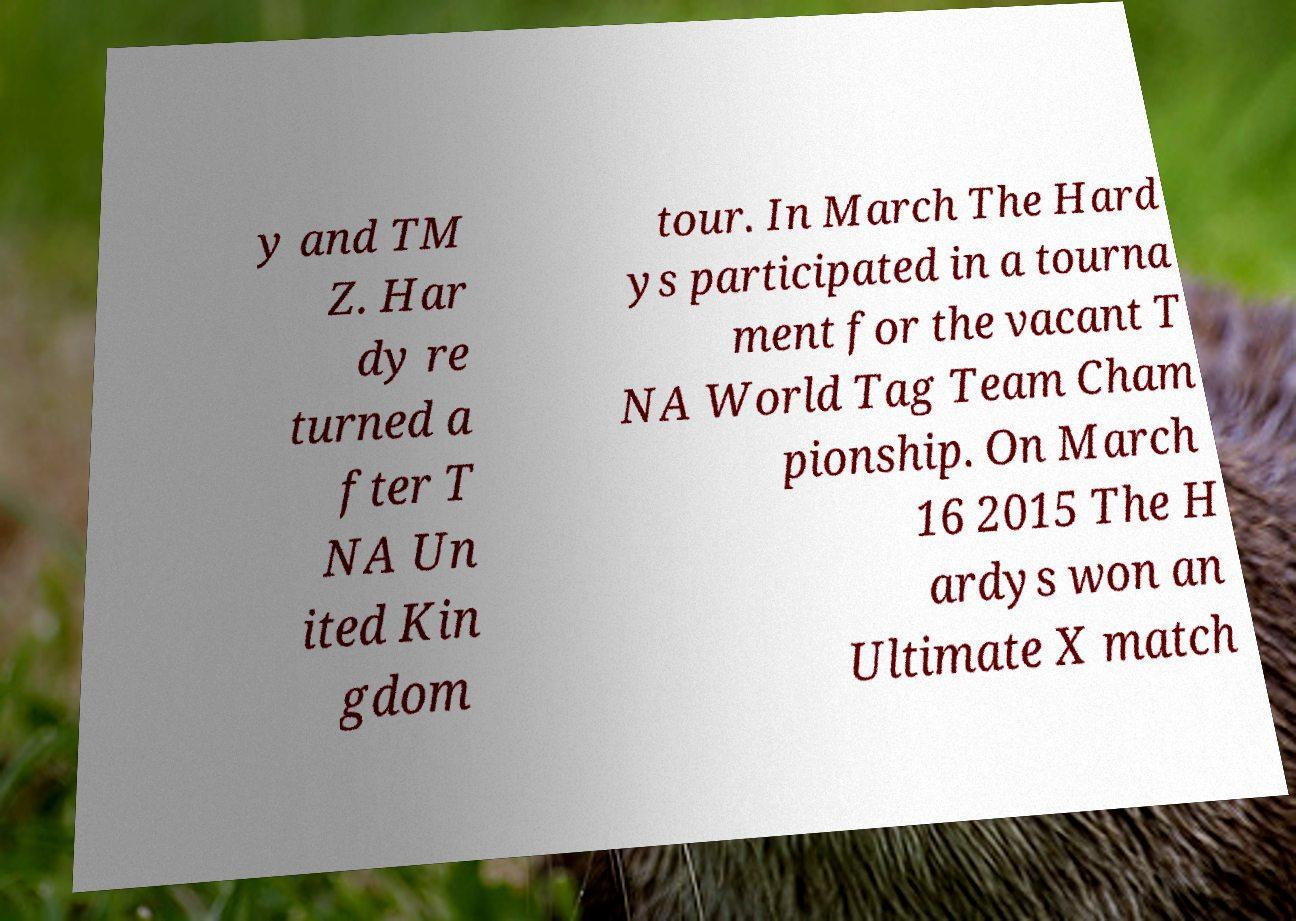Could you assist in decoding the text presented in this image and type it out clearly? y and TM Z. Har dy re turned a fter T NA Un ited Kin gdom tour. In March The Hard ys participated in a tourna ment for the vacant T NA World Tag Team Cham pionship. On March 16 2015 The H ardys won an Ultimate X match 